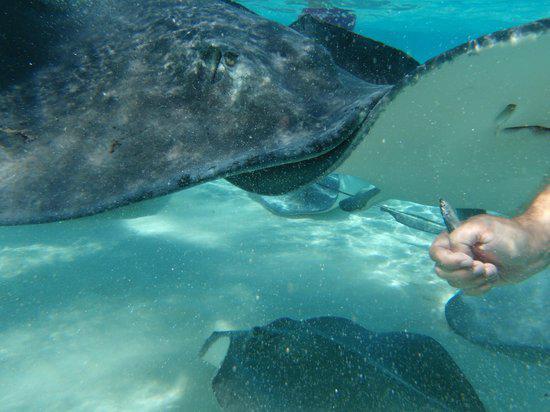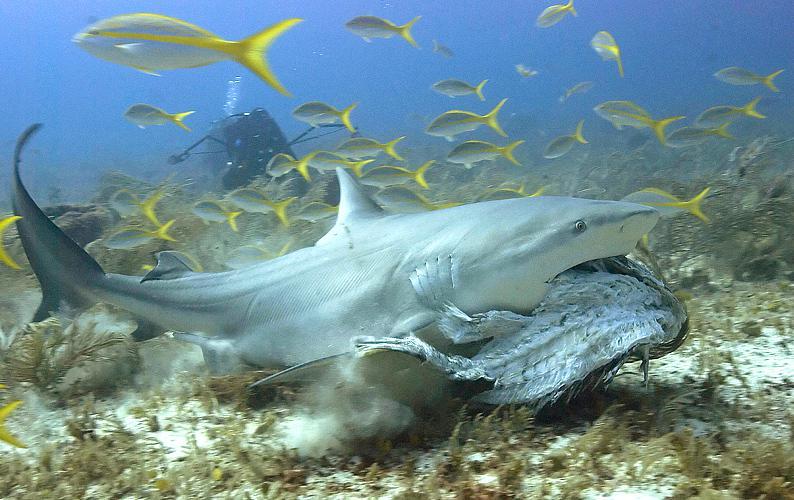The first image is the image on the left, the second image is the image on the right. Assess this claim about the two images: "In one image there is a ray that is swimming very close to the ocean floor.". Correct or not? Answer yes or no. No. The first image is the image on the left, the second image is the image on the right. Assess this claim about the two images: "the left images shows a stingray swimming with the full under belly showing". Correct or not? Answer yes or no. No. 